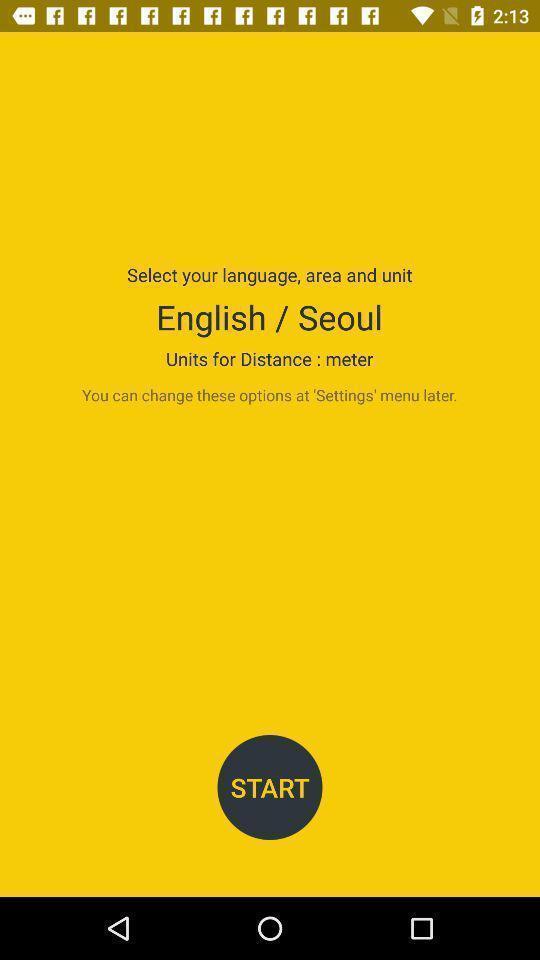Explain the elements present in this screenshot. Welcome page for an application with information related to app. 